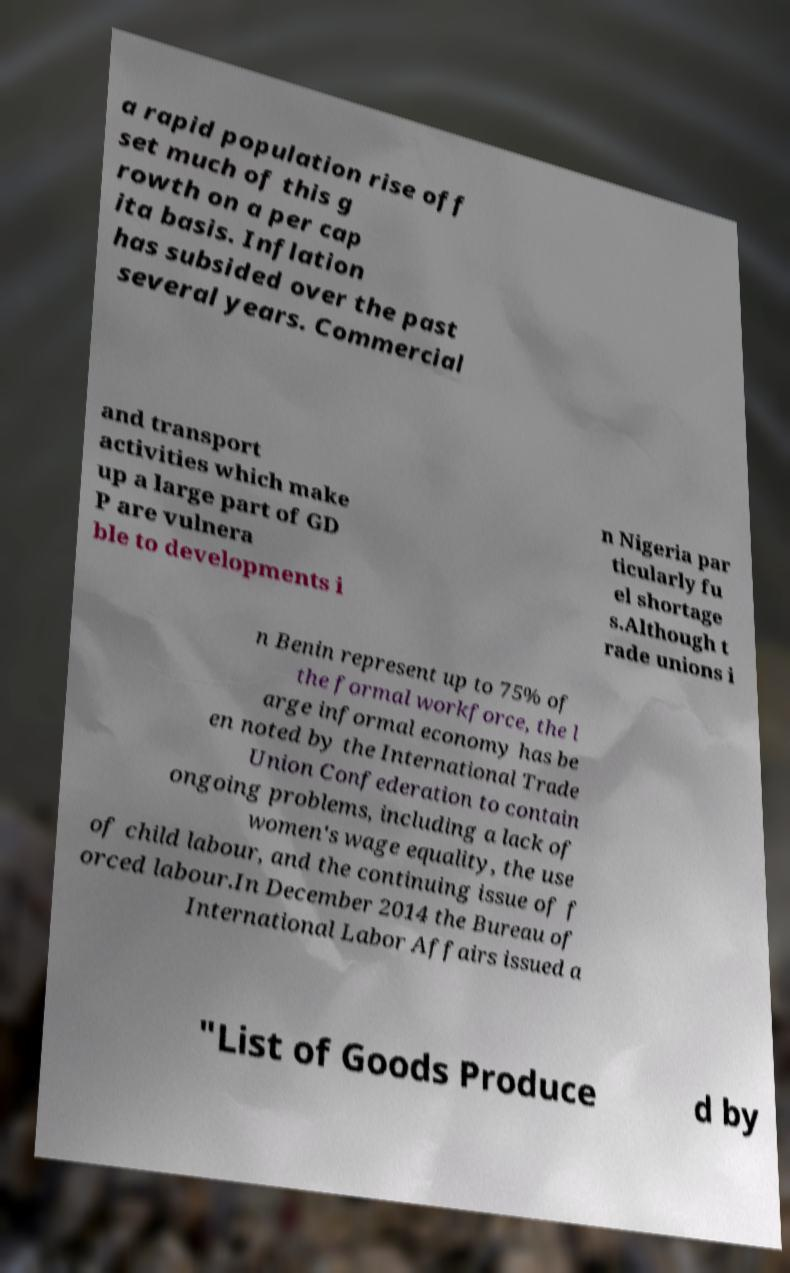I need the written content from this picture converted into text. Can you do that? a rapid population rise off set much of this g rowth on a per cap ita basis. Inflation has subsided over the past several years. Commercial and transport activities which make up a large part of GD P are vulnera ble to developments i n Nigeria par ticularly fu el shortage s.Although t rade unions i n Benin represent up to 75% of the formal workforce, the l arge informal economy has be en noted by the International Trade Union Confederation to contain ongoing problems, including a lack of women's wage equality, the use of child labour, and the continuing issue of f orced labour.In December 2014 the Bureau of International Labor Affairs issued a "List of Goods Produce d by 